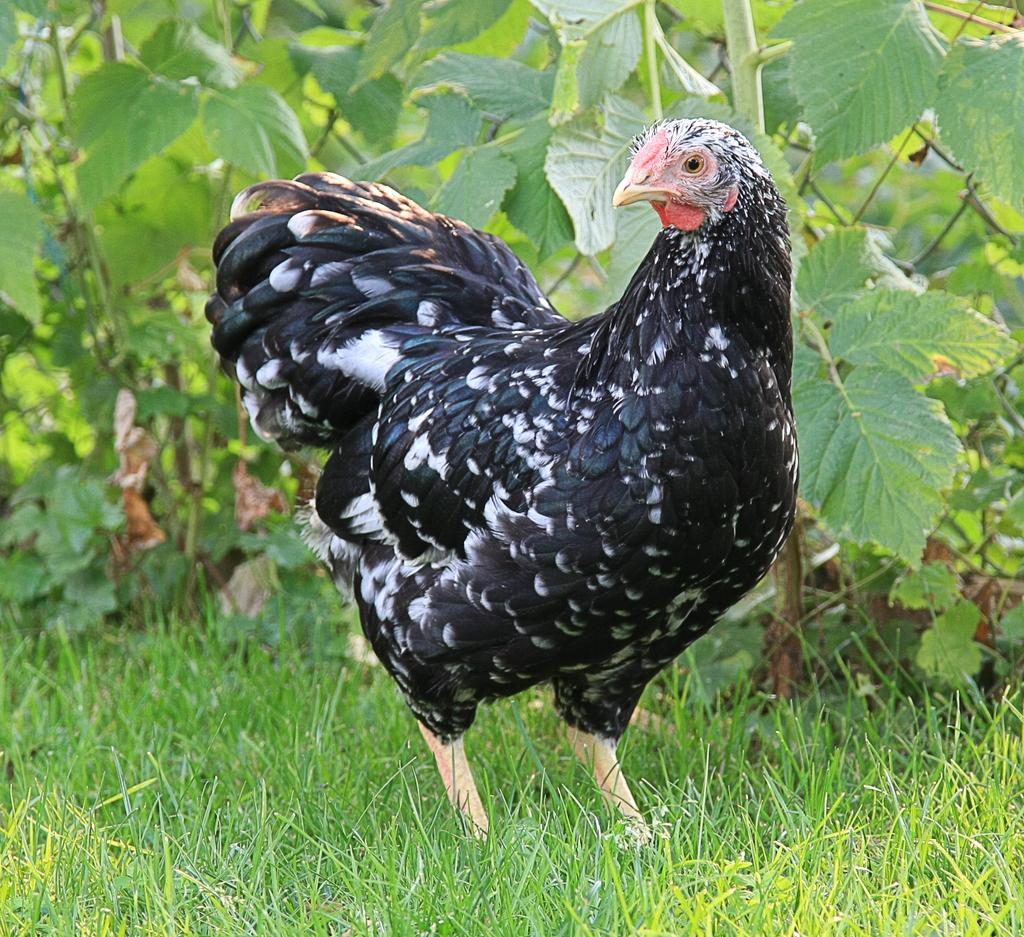What animal can be seen in the image? There is a hen in the image. Where is the hen located? The hen is on the grass. What type of vegetation is visible in the image? There are plants visible in the image. What type of button is the hen using to communicate in the image? There is no button present in the image, and hens do not communicate using buttons. 